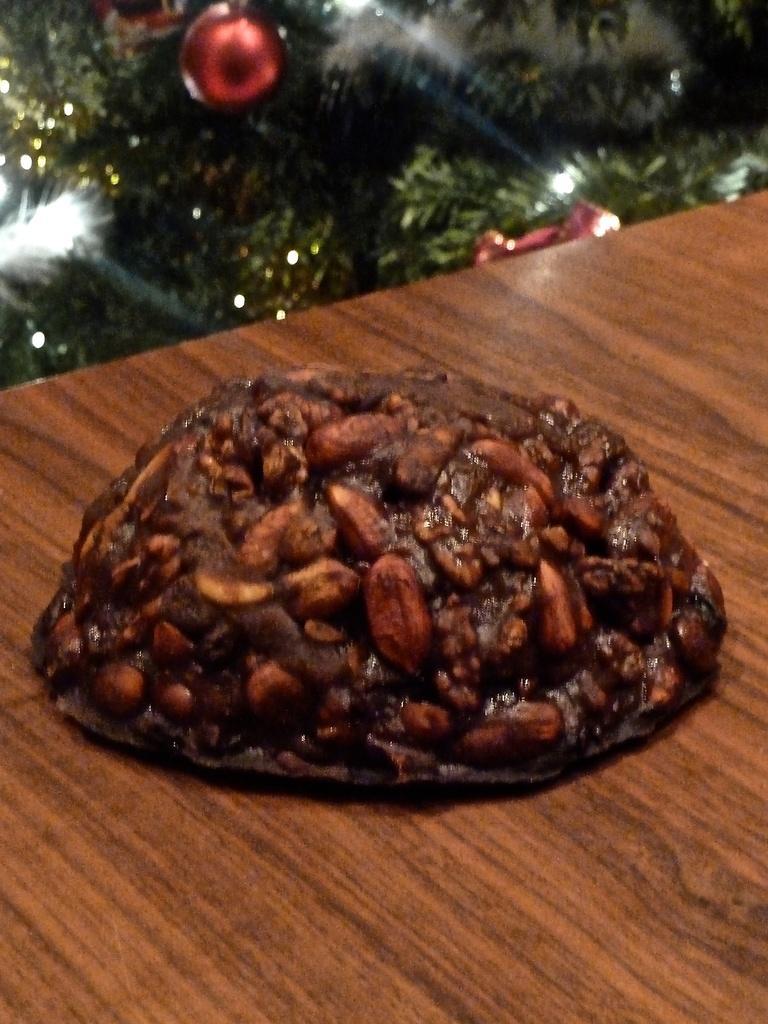Please provide a concise description of this image. In this picture there is food on the table. At the back there is a Christmas tree and there is a ball on the tree. 